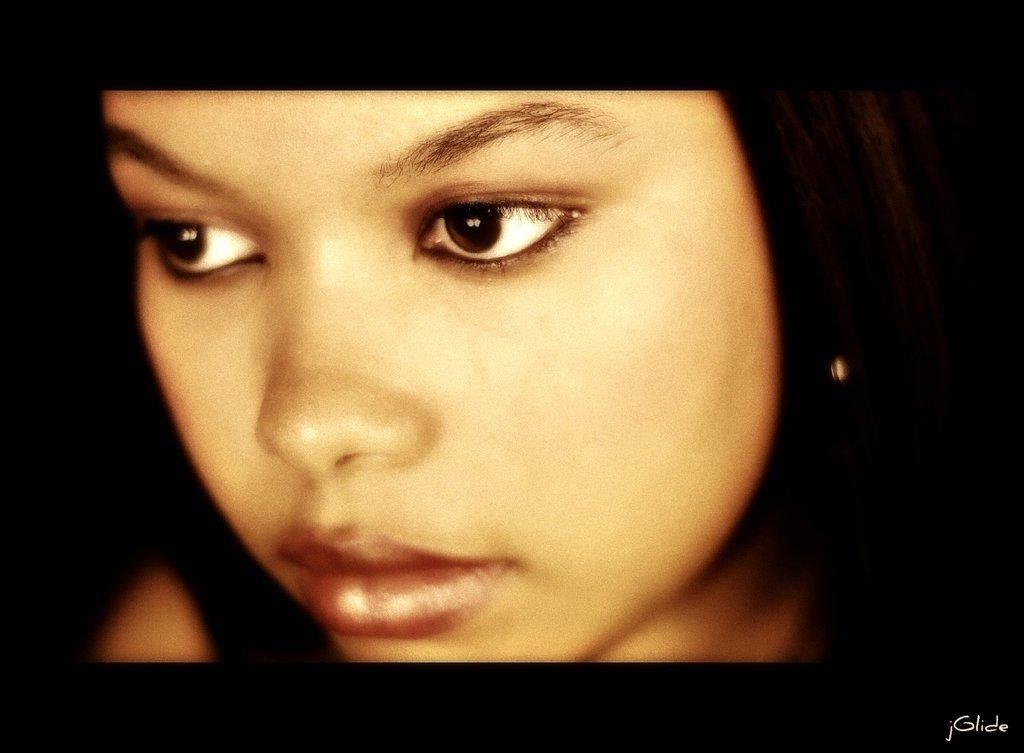Can you describe this image briefly? In this image in the front there is the face of a person. 